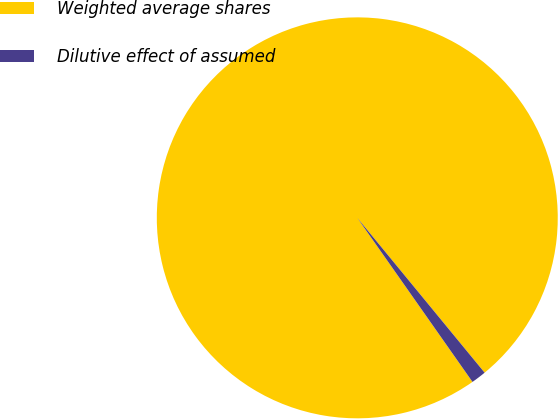Convert chart. <chart><loc_0><loc_0><loc_500><loc_500><pie_chart><fcel>Weighted average shares<fcel>Dilutive effect of assumed<nl><fcel>98.79%<fcel>1.21%<nl></chart> 